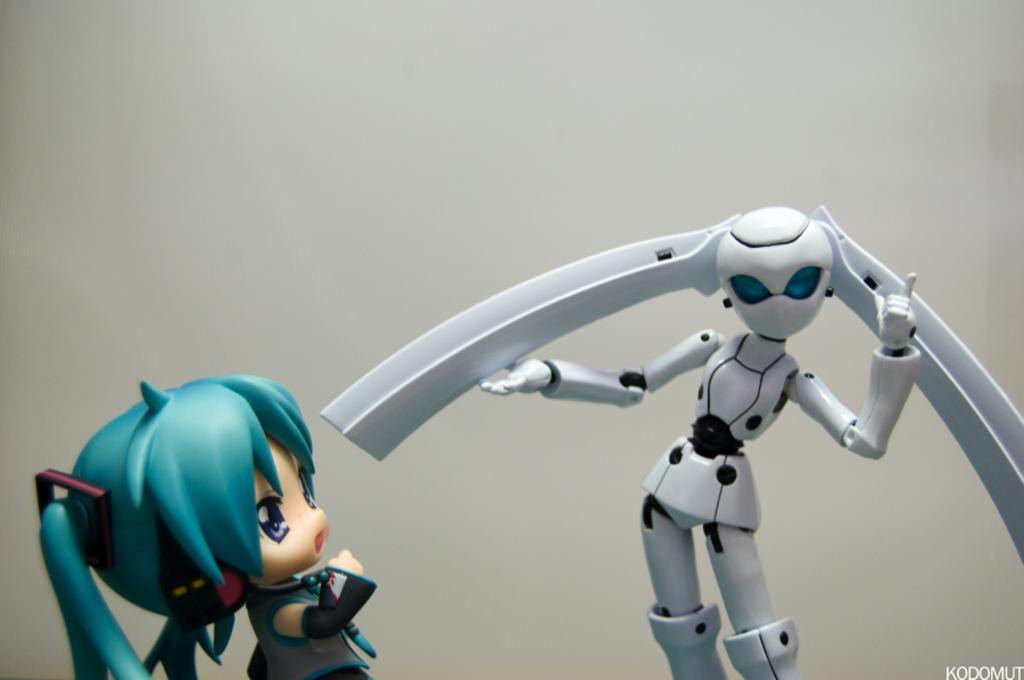Can you describe this image briefly? In this image we can see two toys, some text on the bottom right side of the image and there is a white background. 